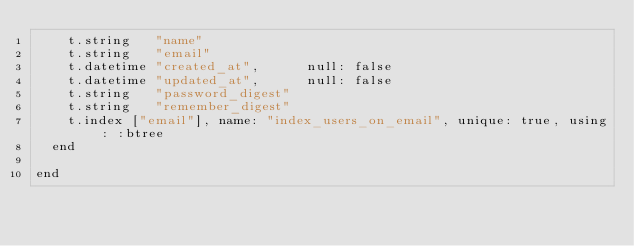<code> <loc_0><loc_0><loc_500><loc_500><_Ruby_>    t.string   "name"
    t.string   "email"
    t.datetime "created_at",      null: false
    t.datetime "updated_at",      null: false
    t.string   "password_digest"
    t.string   "remember_digest"
    t.index ["email"], name: "index_users_on_email", unique: true, using: :btree
  end

end
</code> 